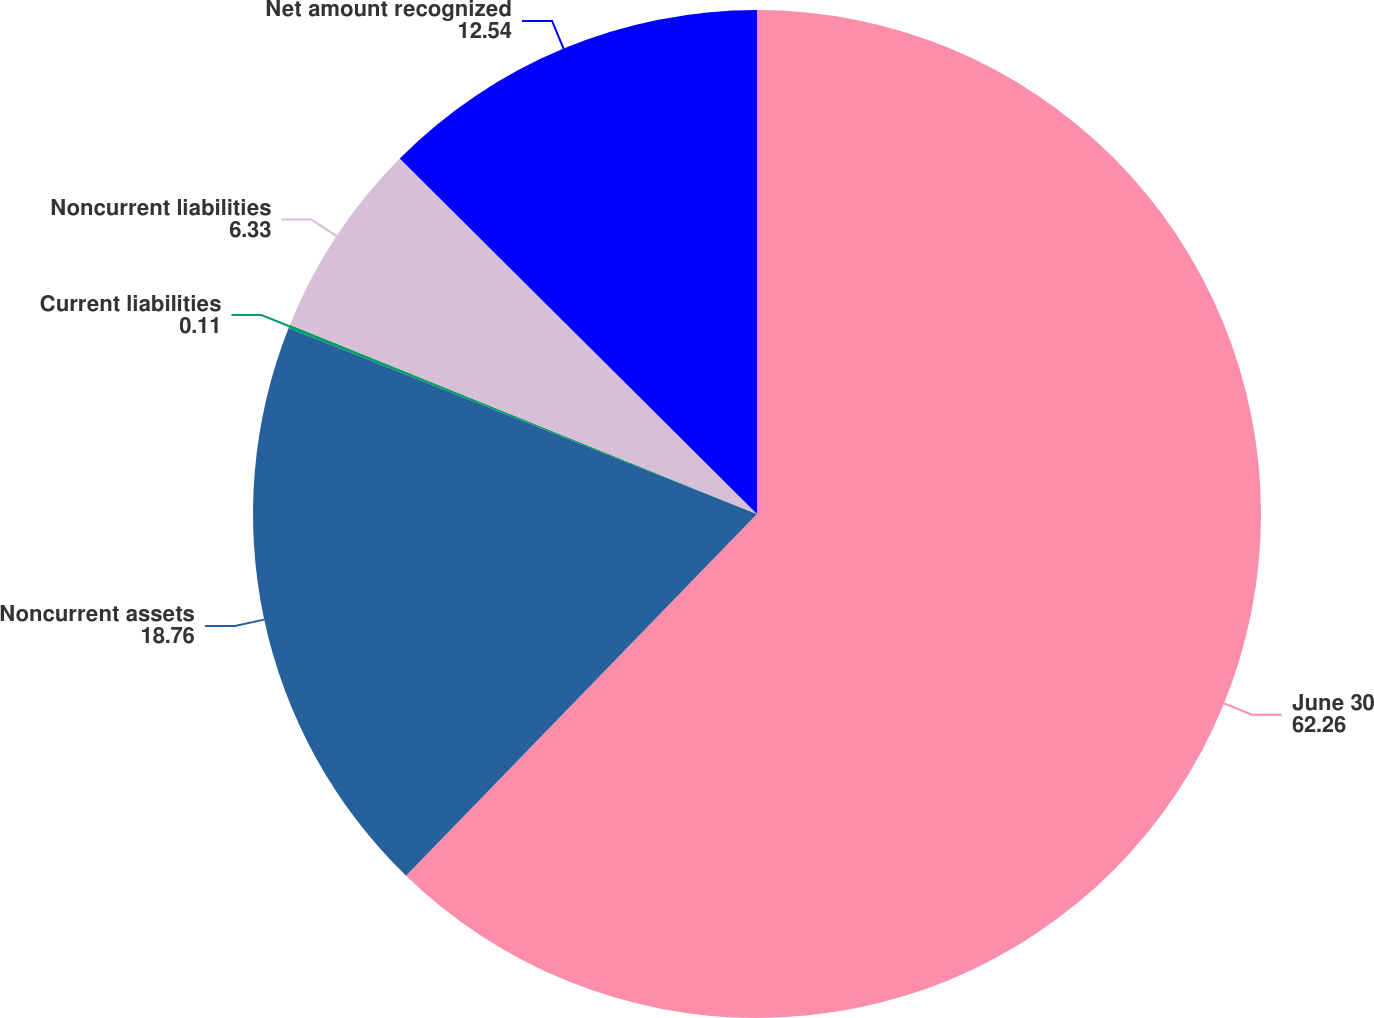<chart> <loc_0><loc_0><loc_500><loc_500><pie_chart><fcel>June 30<fcel>Noncurrent assets<fcel>Current liabilities<fcel>Noncurrent liabilities<fcel>Net amount recognized<nl><fcel>62.26%<fcel>18.76%<fcel>0.11%<fcel>6.33%<fcel>12.54%<nl></chart> 